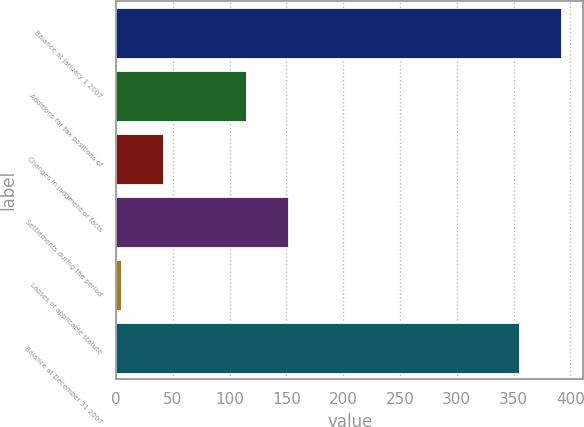<chart> <loc_0><loc_0><loc_500><loc_500><bar_chart><fcel>Balance at January 1 2007<fcel>Additions for tax positions of<fcel>Changes in judgment or facts<fcel>Settlements during the period<fcel>Lapses of applicable statute<fcel>Balance at December 31 2007<nl><fcel>391.9<fcel>114.7<fcel>40.9<fcel>151.6<fcel>4<fcel>355<nl></chart> 